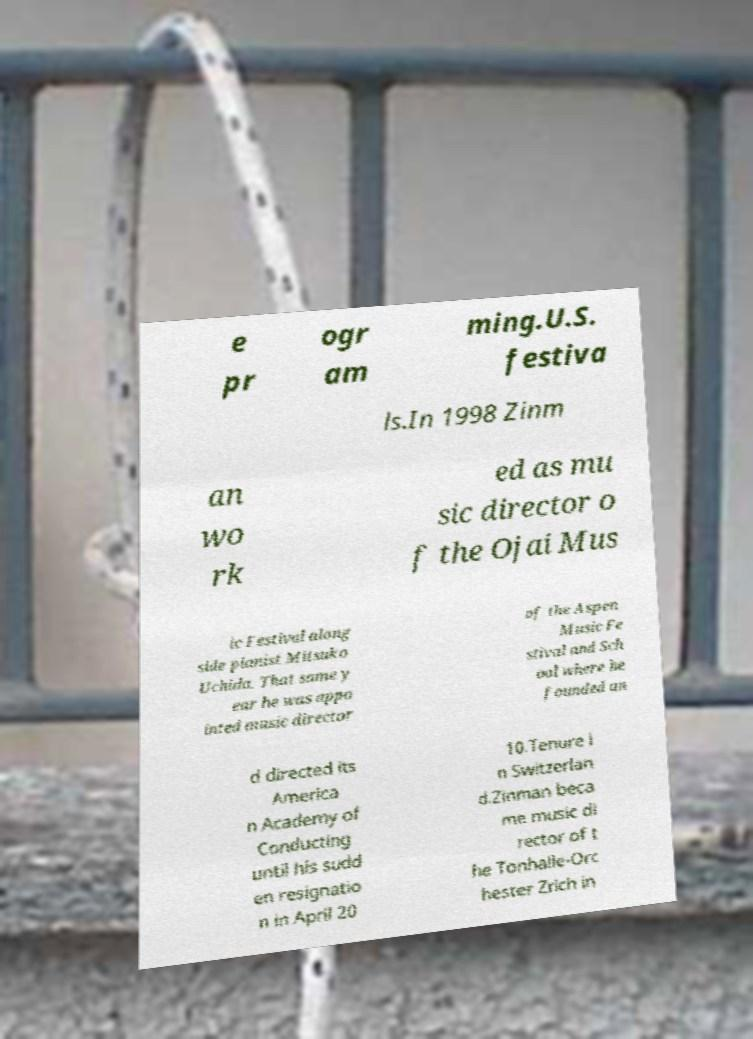For documentation purposes, I need the text within this image transcribed. Could you provide that? e pr ogr am ming.U.S. festiva ls.In 1998 Zinm an wo rk ed as mu sic director o f the Ojai Mus ic Festival along side pianist Mitsuko Uchida. That same y ear he was appo inted music director of the Aspen Music Fe stival and Sch ool where he founded an d directed its America n Academy of Conducting until his sudd en resignatio n in April 20 10.Tenure i n Switzerlan d.Zinman beca me music di rector of t he Tonhalle-Orc hester Zrich in 